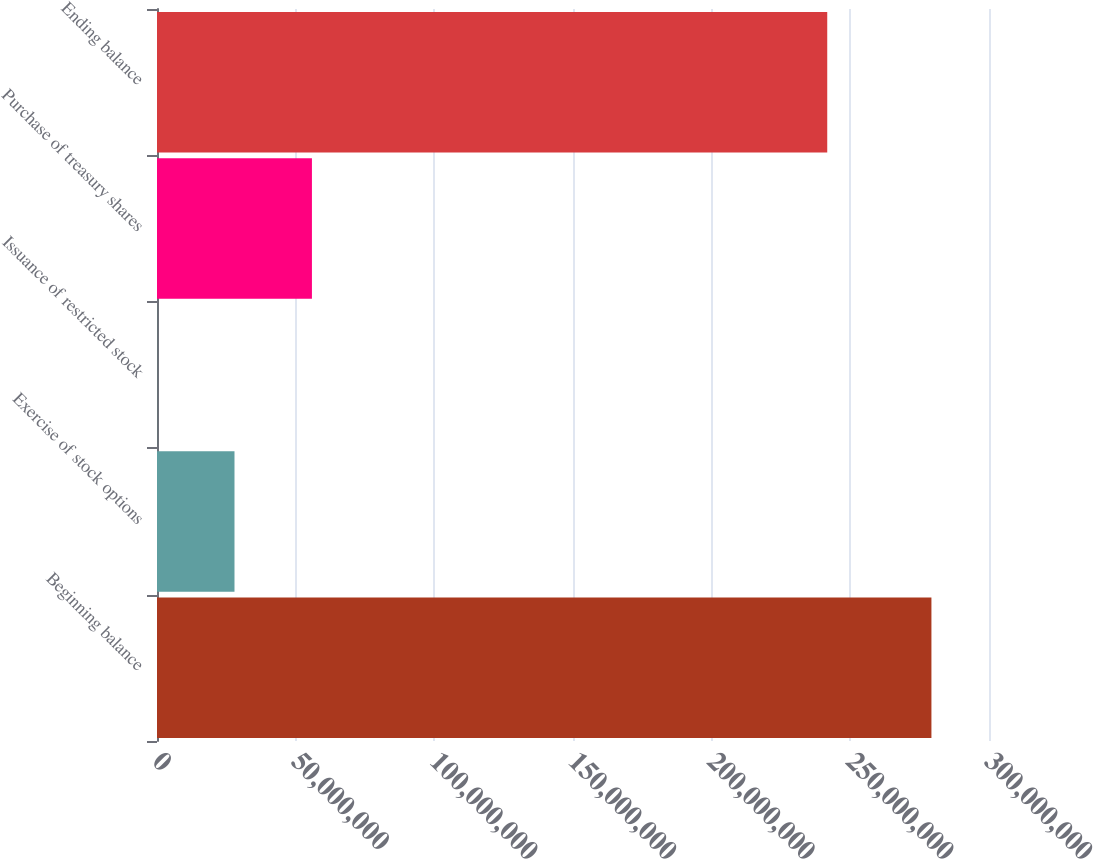<chart> <loc_0><loc_0><loc_500><loc_500><bar_chart><fcel>Beginning balance<fcel>Exercise of stock options<fcel>Issuance of restricted stock<fcel>Purchase of treasury shares<fcel>Ending balance<nl><fcel>2.79241e+08<fcel>2.79429e+07<fcel>20875<fcel>5.58649e+07<fcel>2.41673e+08<nl></chart> 